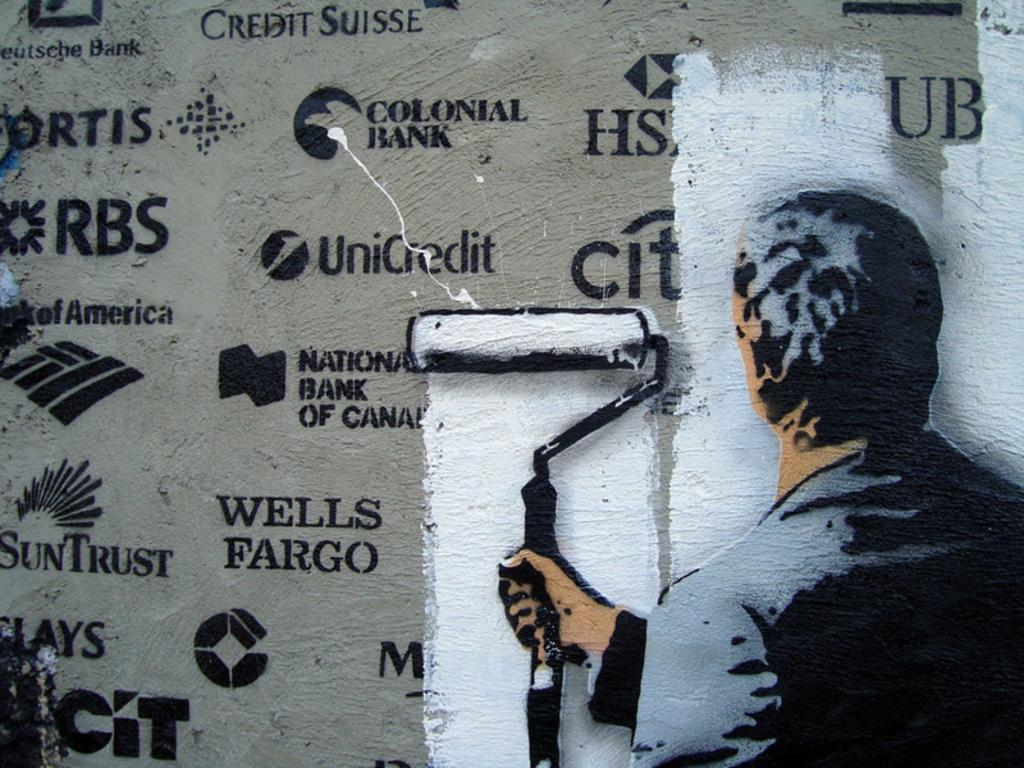<image>
Share a concise interpretation of the image provided. Man painting over a wall full of logos including Wells Fargo. 